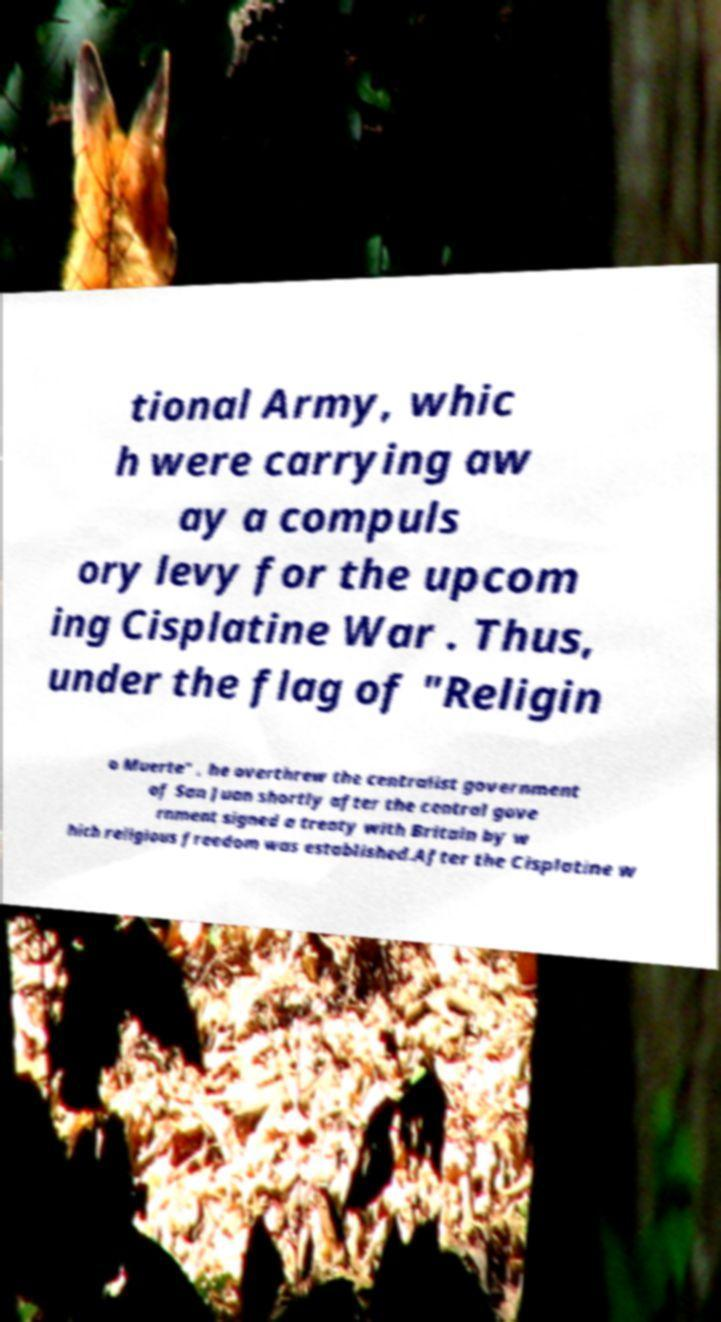Could you assist in decoding the text presented in this image and type it out clearly? tional Army, whic h were carrying aw ay a compuls ory levy for the upcom ing Cisplatine War . Thus, under the flag of "Religin o Muerte" , he overthrew the centralist government of San Juan shortly after the central gove rnment signed a treaty with Britain by w hich religious freedom was established.After the Cisplatine w 